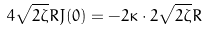<formula> <loc_0><loc_0><loc_500><loc_500>4 \sqrt { 2 \zeta } R J ( 0 ) = - 2 \kappa \cdot 2 \sqrt { 2 \zeta } R</formula> 